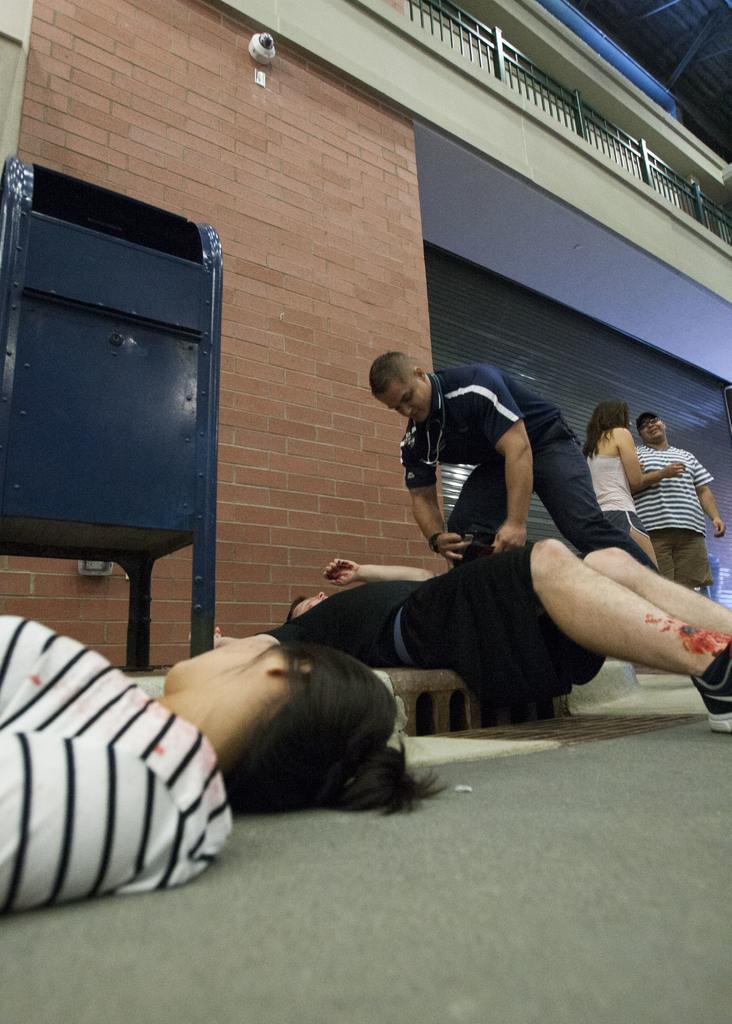How many people are in the image? There are persons in the image, but the exact number is not specified. What is the main feature of the image? The main feature of the image is a road. What can be seen in the background of the image? In the background of the image, there is a building, a wall, and a bin. What type of beds are available for purchase in the image? There are no beds present in the image. How much profit can be made from the persons in the image? There is no information about profit or commerce in the image. 